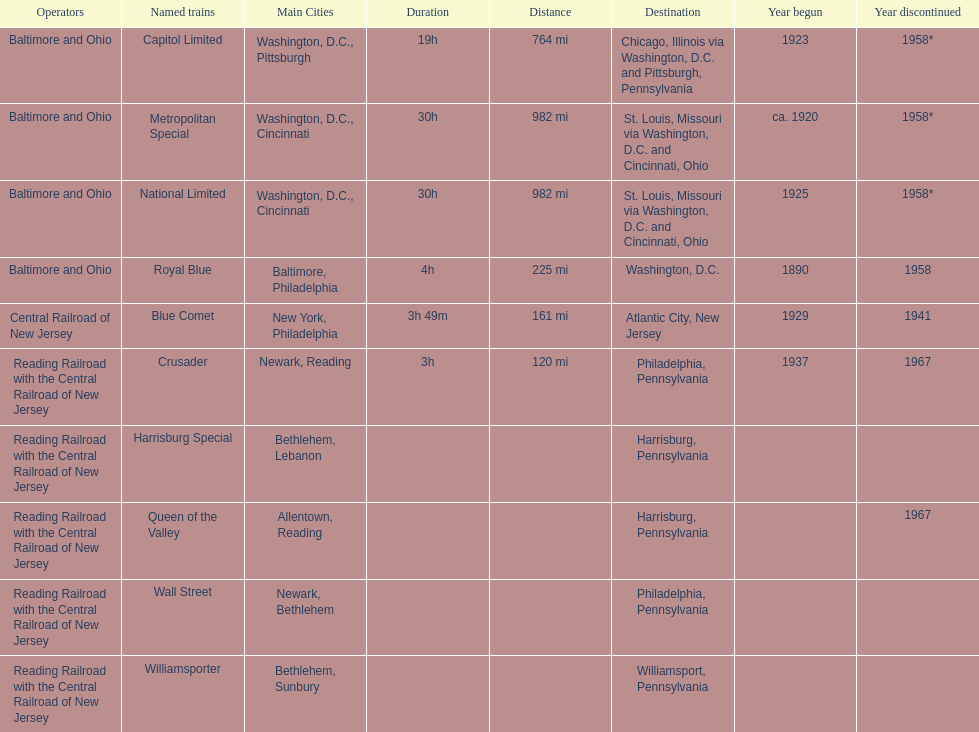Which spot is at the peak of the list? Chicago, Illinois via Washington, D.C. and Pittsburgh, Pennsylvania. 